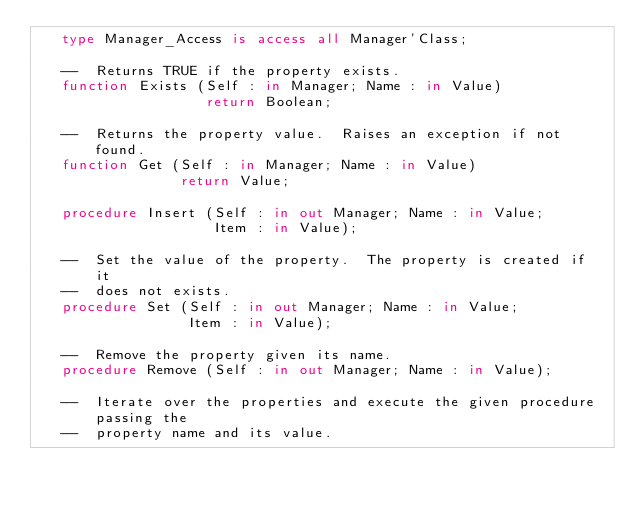Convert code to text. <code><loc_0><loc_0><loc_500><loc_500><_Ada_>   type Manager_Access is access all Manager'Class;

   --  Returns TRUE if the property exists.
   function Exists (Self : in Manager; Name : in Value)
                    return Boolean;

   --  Returns the property value.  Raises an exception if not found.
   function Get (Self : in Manager; Name : in Value)
                 return Value;

   procedure Insert (Self : in out Manager; Name : in Value;
                     Item : in Value);

   --  Set the value of the property.  The property is created if it
   --  does not exists.
   procedure Set (Self : in out Manager; Name : in Value;
                  Item : in Value);

   --  Remove the property given its name.
   procedure Remove (Self : in out Manager; Name : in Value);

   --  Iterate over the properties and execute the given procedure passing the
   --  property name and its value.</code> 